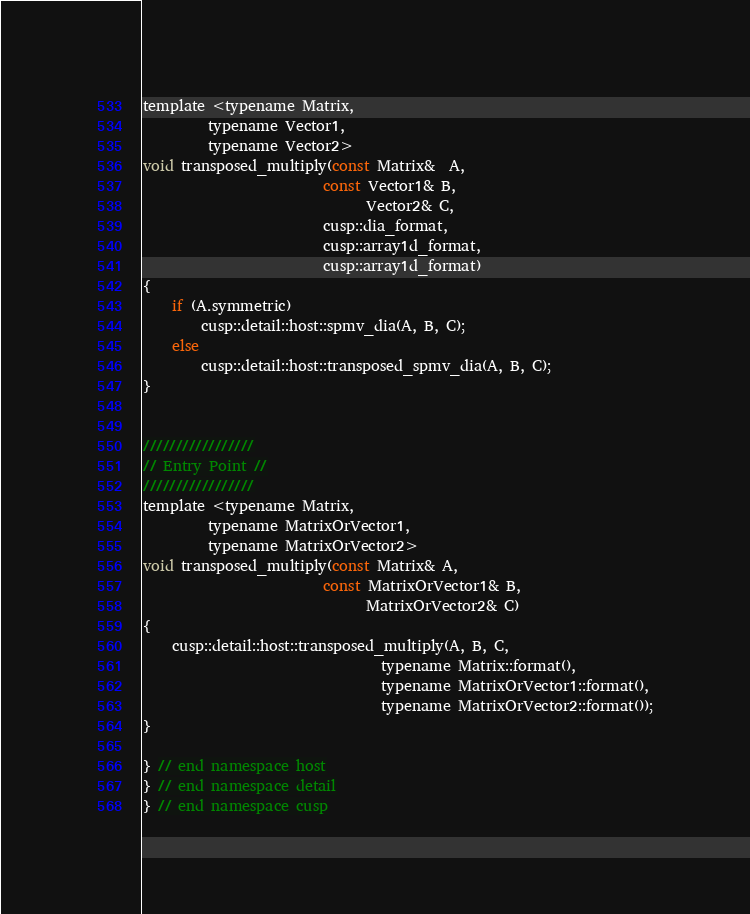<code> <loc_0><loc_0><loc_500><loc_500><_C_>
template <typename Matrix,
         typename Vector1,
         typename Vector2>
void transposed_multiply(const Matrix&  A,
                         const Vector1& B,
                               Vector2& C,
                         cusp::dia_format,
                         cusp::array1d_format,
                         cusp::array1d_format)
{
    if (A.symmetric)
        cusp::detail::host::spmv_dia(A, B, C);
    else
        cusp::detail::host::transposed_spmv_dia(A, B, C);
}


/////////////////
// Entry Point //
/////////////////
template <typename Matrix,
         typename MatrixOrVector1,
         typename MatrixOrVector2>
void transposed_multiply(const Matrix& A,
                         const MatrixOrVector1& B,
                               MatrixOrVector2& C)
{
    cusp::detail::host::transposed_multiply(A, B, C,
                                 typename Matrix::format(),
                                 typename MatrixOrVector1::format(),
                                 typename MatrixOrVector2::format());
}

} // end namespace host
} // end namespace detail
} // end namespace cusp

</code> 